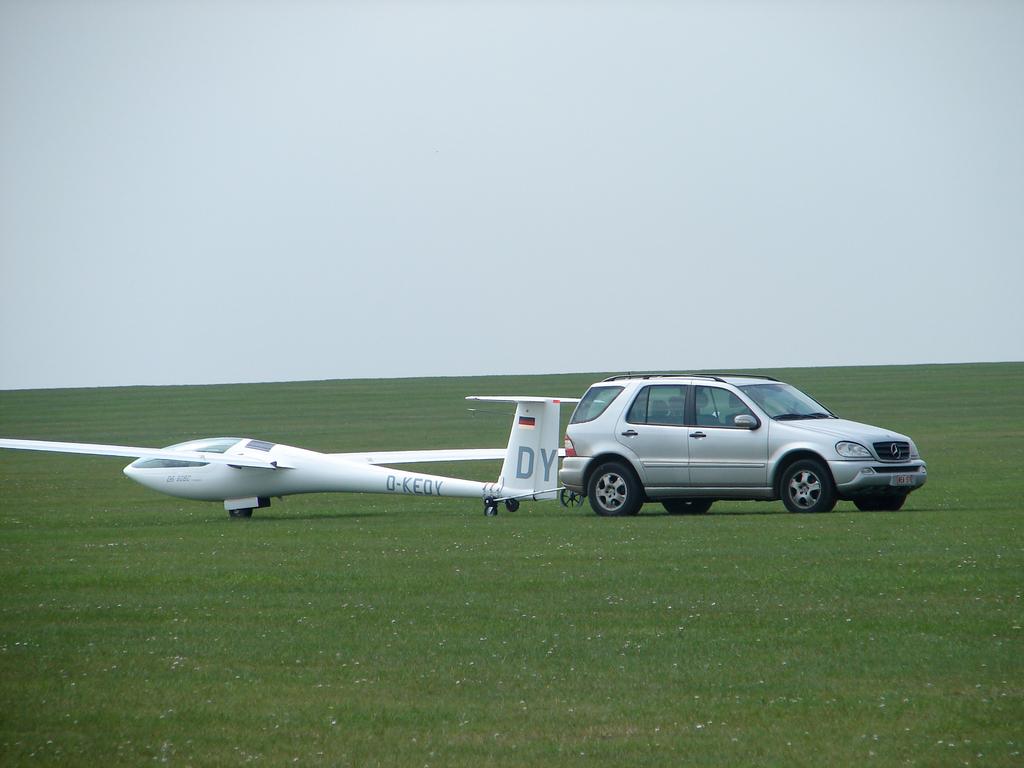What is on the tail?
Offer a very short reply. Dy. What is on the fuselage?
Provide a short and direct response. Dy. 